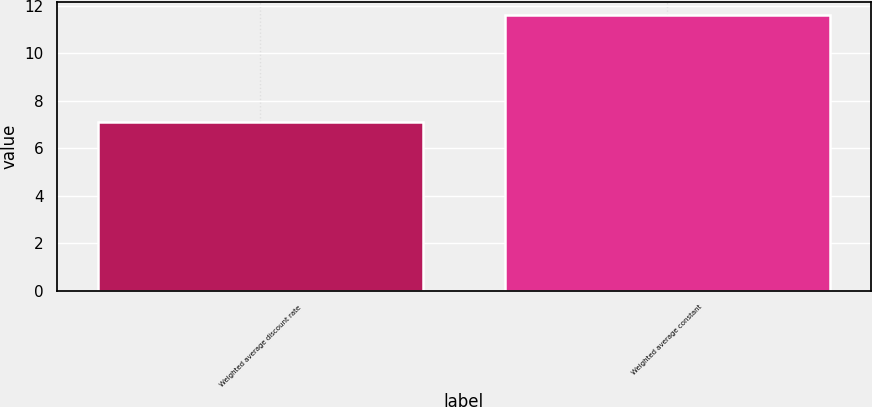Convert chart to OTSL. <chart><loc_0><loc_0><loc_500><loc_500><bar_chart><fcel>Weighted average discount rate<fcel>Weighted average constant<nl><fcel>7.1<fcel>11.6<nl></chart> 